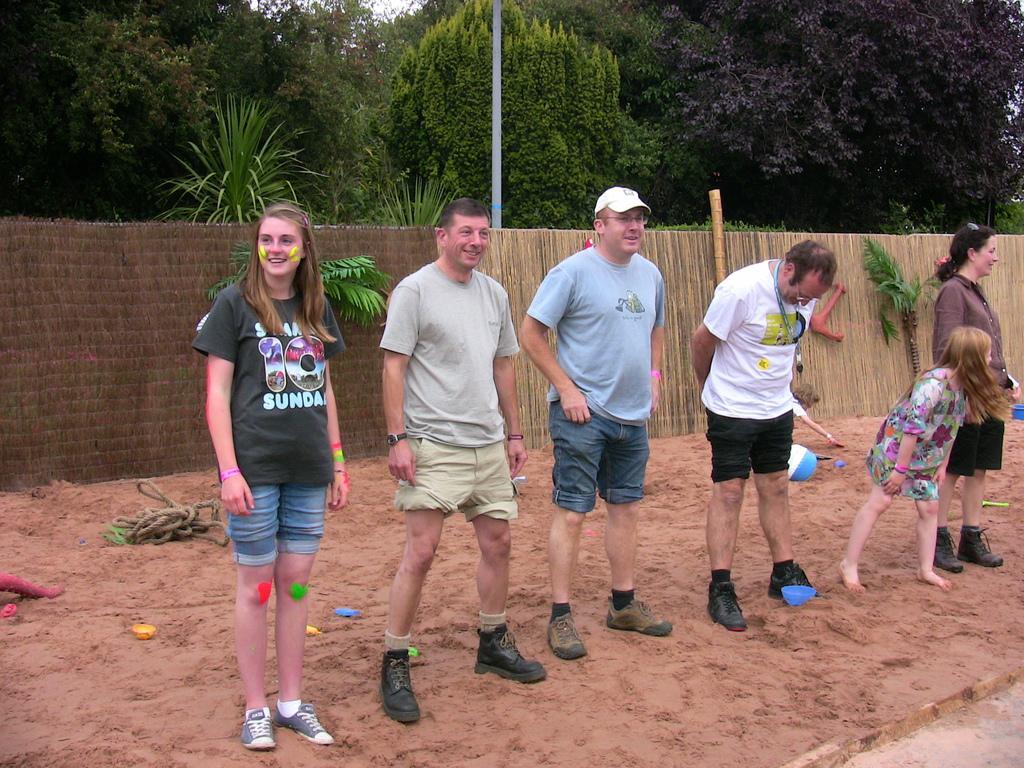Can you describe this image briefly? In this image there are people standing on the sand. Behind them there is a ball. There is a rope and there are a few other objects. In the background of the image there is a wall. There are trees and there is a pole. 